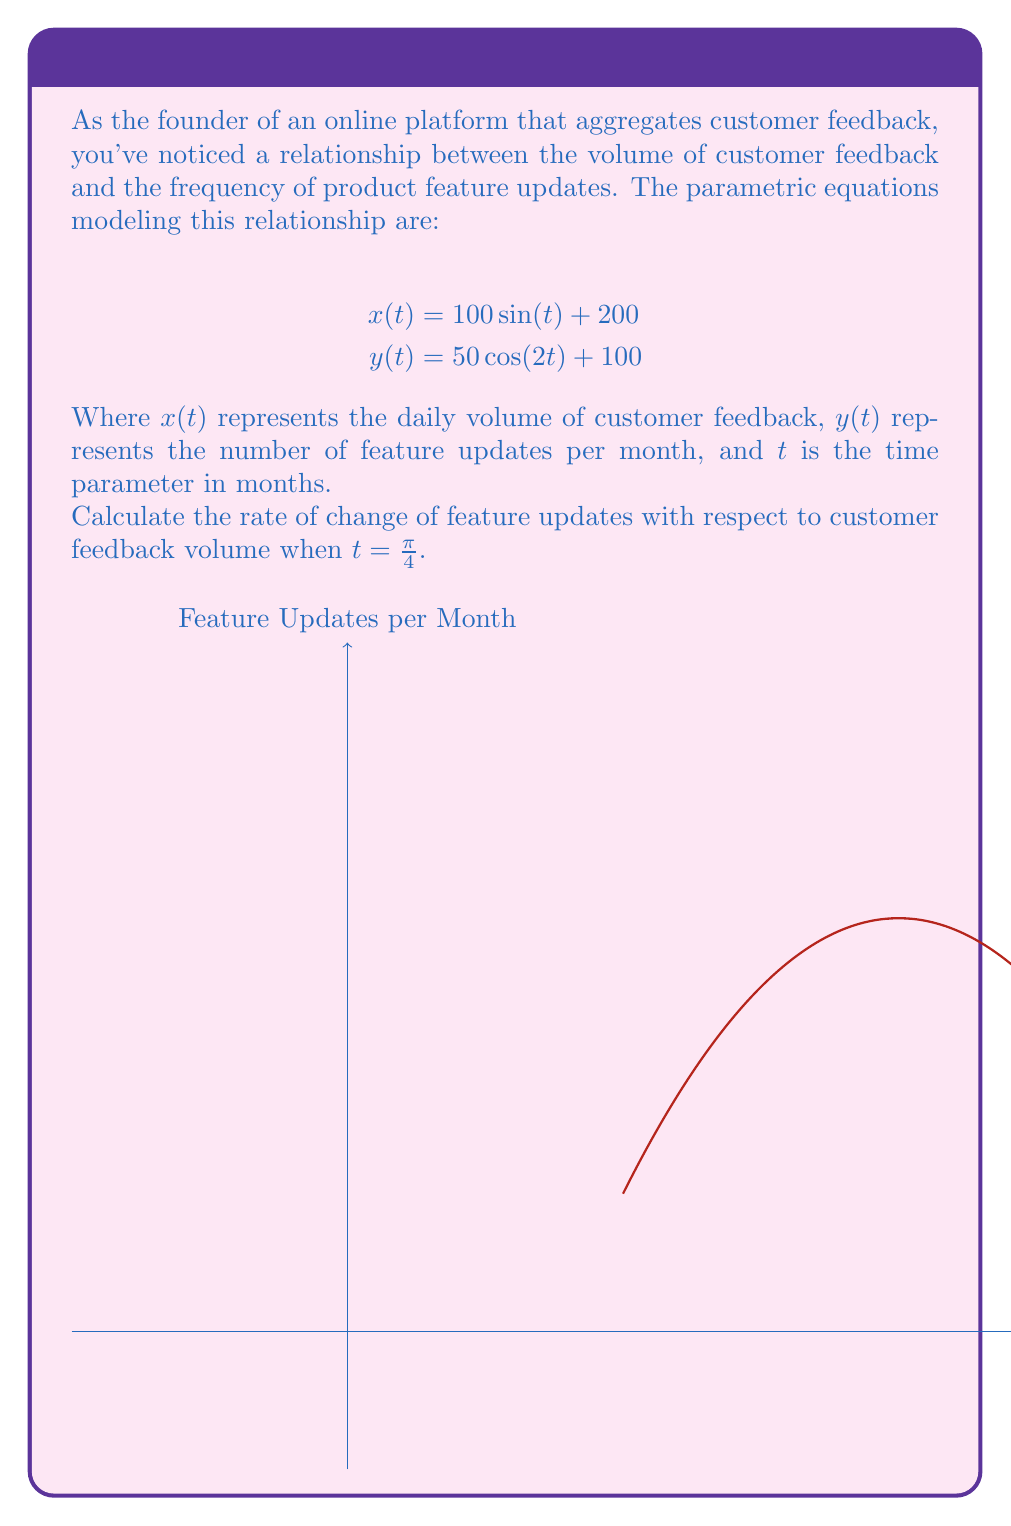Could you help me with this problem? To solve this problem, we'll follow these steps:

1) First, we need to find $\frac{dy}{dx}$ using the chain rule:

   $$\frac{dy}{dx} = \frac{dy/dt}{dx/dt}$$

2) Calculate $\frac{dx}{dt}$:
   $$\frac{dx}{dt} = 100\cos(t)$$

3) Calculate $\frac{dy}{dt}$:
   $$\frac{dy}{dt} = -100\sin(2t)$$

4) Now we can express $\frac{dy}{dx}$:
   $$\frac{dy}{dx} = \frac{-100\sin(2t)}{100\cos(t)} = -\frac{\sin(2t)}{\cos(t)}$$

5) We need to evaluate this at $t = \frac{\pi}{4}$. Let's substitute:
   $$\frac{dy}{dx}\bigg|_{t=\frac{\pi}{4}} = -\frac{\sin(2\cdot\frac{\pi}{4})}{\cos(\frac{\pi}{4})} = -\frac{\sin(\frac{\pi}{2})}{\cos(\frac{\pi}{4})}$$

6) Simplify:
   $$-\frac{1}{\frac{\sqrt{2}}{2}} = -\frac{2}{\sqrt{2}} = -\sqrt{2}$$

Therefore, when $t = \frac{\pi}{4}$, the rate of change of feature updates with respect to customer feedback volume is $-\sqrt{2}$ updates per feedback unit.
Answer: $-\sqrt{2}$ updates per feedback unit 